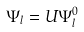<formula> <loc_0><loc_0><loc_500><loc_500>\Psi _ { l } = U \Psi _ { l } ^ { 0 }</formula> 